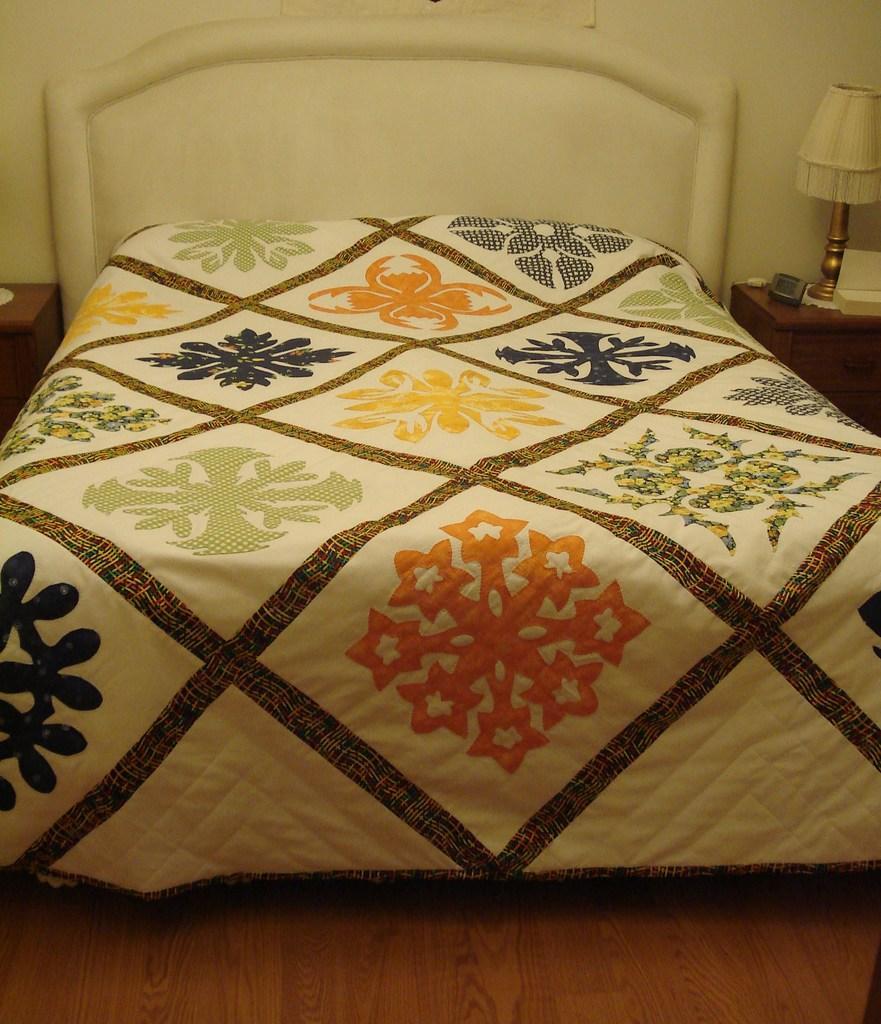Could you give a brief overview of what you see in this image? In this image I can see a bed which is in white color and I can also see multicolor blanket. Background I can see a lamp on the table and the wall is in white color. 